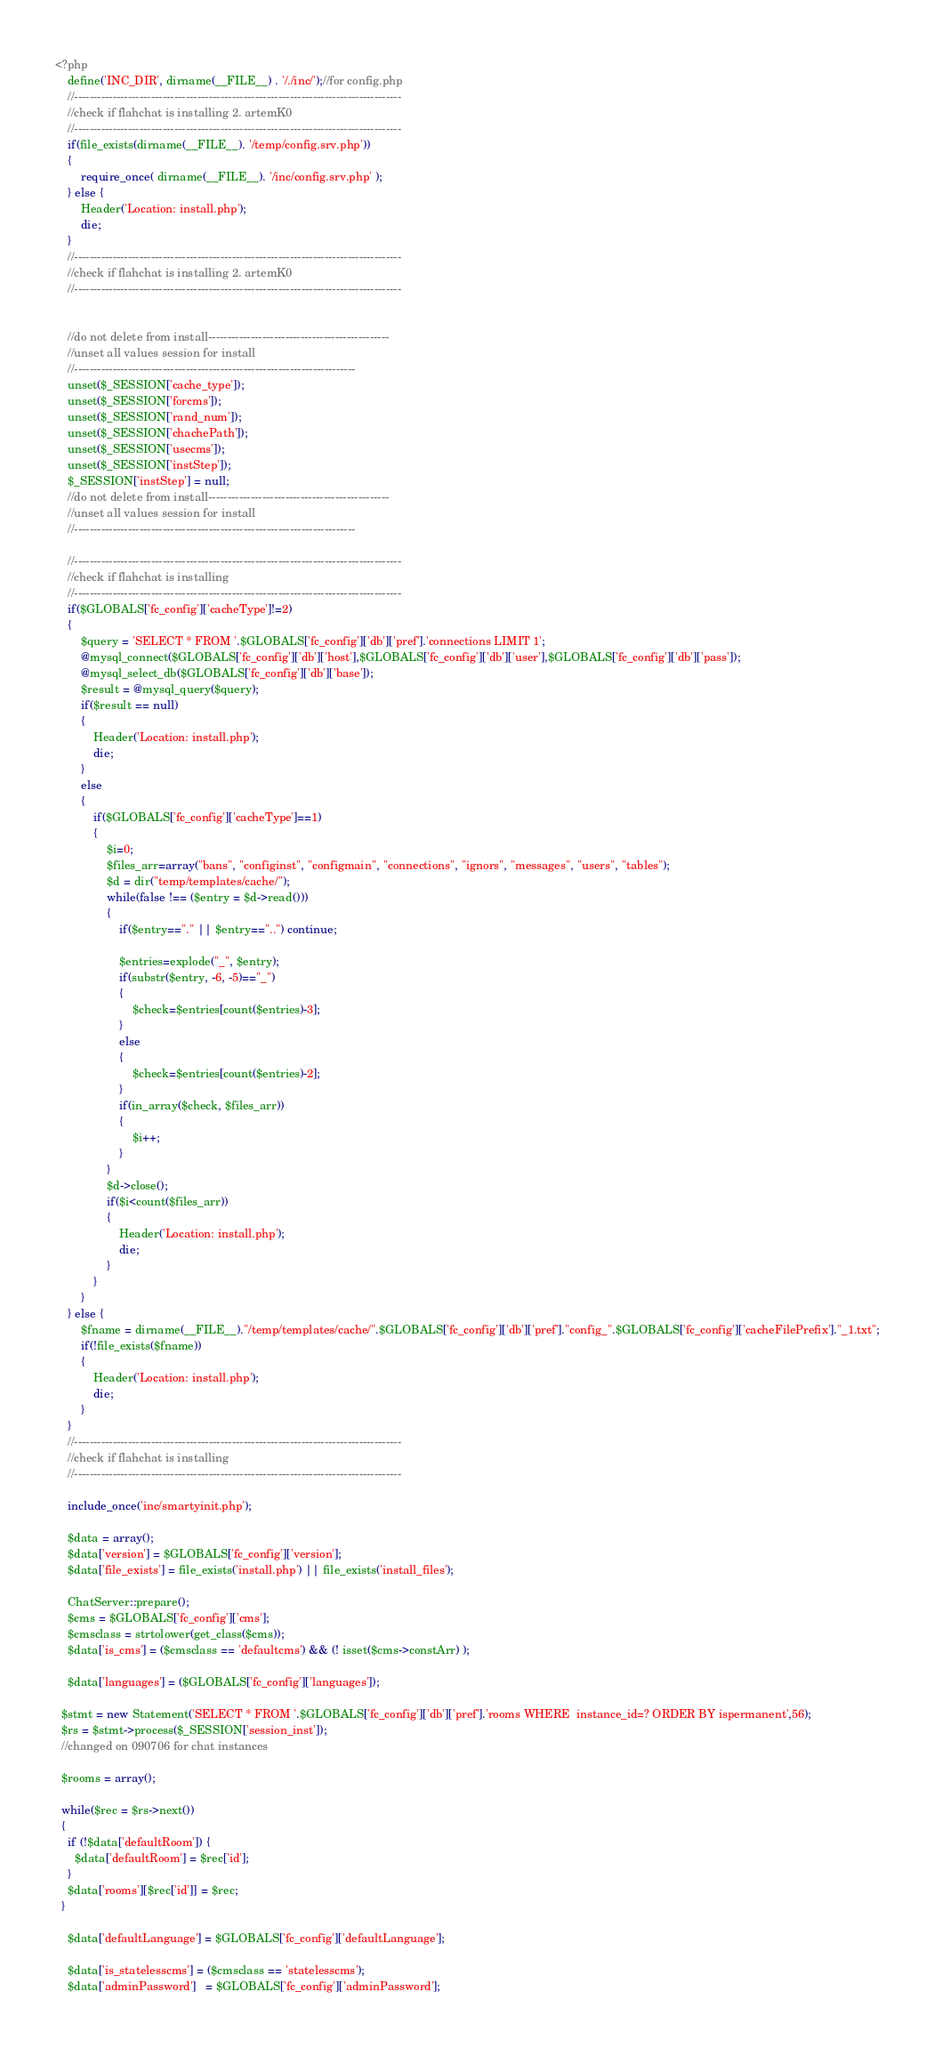<code> <loc_0><loc_0><loc_500><loc_500><_PHP_><?php
	define('INC_DIR', dirname(__FILE__) . '/./inc/');//for config.php
	//-------------------------------------------------------------------------------------
	//check if flahchat is installing 2. artemK0
	//-------------------------------------------------------------------------------------
	if(file_exists(dirname(__FILE__). '/temp/config.srv.php'))
	{
		require_once( dirname(__FILE__). '/inc/config.srv.php' );
	} else {
		Header('Location: install.php');
		die;
	}
	//-------------------------------------------------------------------------------------
	//check if flahchat is installing 2. artemK0
	//-------------------------------------------------------------------------------------


	//do not delete from install-----------------------------------------------
	//unset all values session for install
	//-------------------------------------------------------------------------
	unset($_SESSION['cache_type']);
	unset($_SESSION['forcms']);
	unset($_SESSION['rand_num']);
	unset($_SESSION['chachePath']);
	unset($_SESSION['usecms']);
	unset($_SESSION['instStep']);
	$_SESSION['instStep'] = null;
	//do not delete from install-----------------------------------------------
	//unset all values session for install
	//-------------------------------------------------------------------------

	//-------------------------------------------------------------------------------------
	//check if flahchat is installing
	//-------------------------------------------------------------------------------------
	if($GLOBALS['fc_config']['cacheType']!=2)
	{
		$query = 'SELECT * FROM '.$GLOBALS['fc_config']['db']['pref'].'connections LIMIT 1';
		@mysql_connect($GLOBALS['fc_config']['db']['host'],$GLOBALS['fc_config']['db']['user'],$GLOBALS['fc_config']['db']['pass']);
		@mysql_select_db($GLOBALS['fc_config']['db']['base']);
		$result = @mysql_query($query);
		if($result == null)
		{
			Header('Location: install.php');
			die;
		}
		else
		{
			if($GLOBALS['fc_config']['cacheType']==1)
			{
				$i=0;
				$files_arr=array("bans", "configinst", "configmain", "connections", "ignors", "messages", "users", "tables");
				$d = dir("temp/templates/cache/");
				while(false !== ($entry = $d->read()))
				{
					if($entry=="." || $entry=="..") continue;

					$entries=explode("_", $entry);
					if(substr($entry, -6, -5)=="_")
					{
						$check=$entries[count($entries)-3];
					}
					else
					{
						$check=$entries[count($entries)-2];
					}
					if(in_array($check, $files_arr))
					{
						$i++;
					}
				}
				$d->close();
				if($i<count($files_arr))
				{
					Header('Location: install.php');
					die;
				}
			}
		}
	} else {
		$fname = dirname(__FILE__)."/temp/templates/cache/".$GLOBALS['fc_config']['db']['pref']."config_".$GLOBALS['fc_config']['cacheFilePrefix']."_1.txt";
		if(!file_exists($fname))
		{
			Header('Location: install.php');
			die;
		}
	}
	//-------------------------------------------------------------------------------------
	//check if flahchat is installing
	//-------------------------------------------------------------------------------------

	include_once('inc/smartyinit.php');

	$data = array();
	$data['version'] = $GLOBALS['fc_config']['version'];
	$data['file_exists'] = file_exists('install.php') || file_exists('install_files');

	ChatServer::prepare();
	$cms = $GLOBALS['fc_config']['cms'];
	$cmsclass = strtolower(get_class($cms));
	$data['is_cms'] = ($cmsclass == 'defaultcms') && (! isset($cms->constArr) );

	$data['languages'] = ($GLOBALS['fc_config']['languages']);

  $stmt = new Statement('SELECT * FROM '.$GLOBALS['fc_config']['db']['pref'].'rooms WHERE  instance_id=? ORDER BY ispermanent',56);
  $rs = $stmt->process($_SESSION['session_inst']);
  //changed on 090706 for chat instances

  $rooms = array();

  while($rec = $rs->next())
  {
    if (!$data['defaultRoom']) {
      $data['defaultRoom'] = $rec['id'];
    }
    $data['rooms'][$rec['id']] = $rec;
  }

	$data['defaultLanguage'] = $GLOBALS['fc_config']['defaultLanguage'];

	$data['is_statelesscms'] = ($cmsclass == 'statelesscms');
	$data['adminPassword']   = $GLOBALS['fc_config']['adminPassword'];</code> 